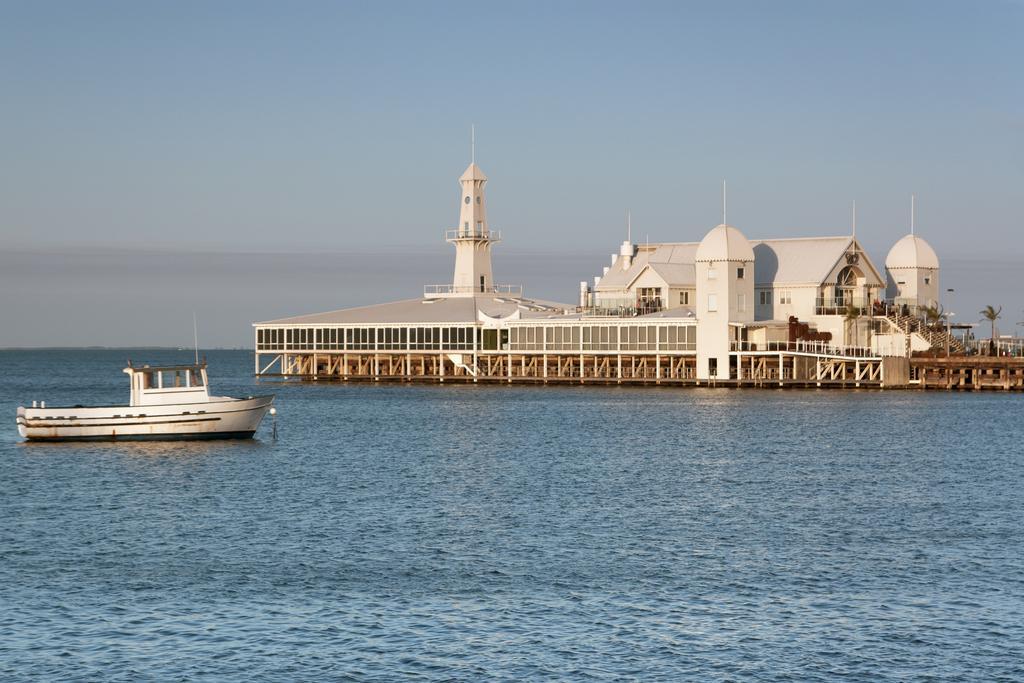In one or two sentences, can you explain what this image depicts? In this image I can see a boat which is in white color on the water, background I can see a house in white color and the sky is in white and blue color. 